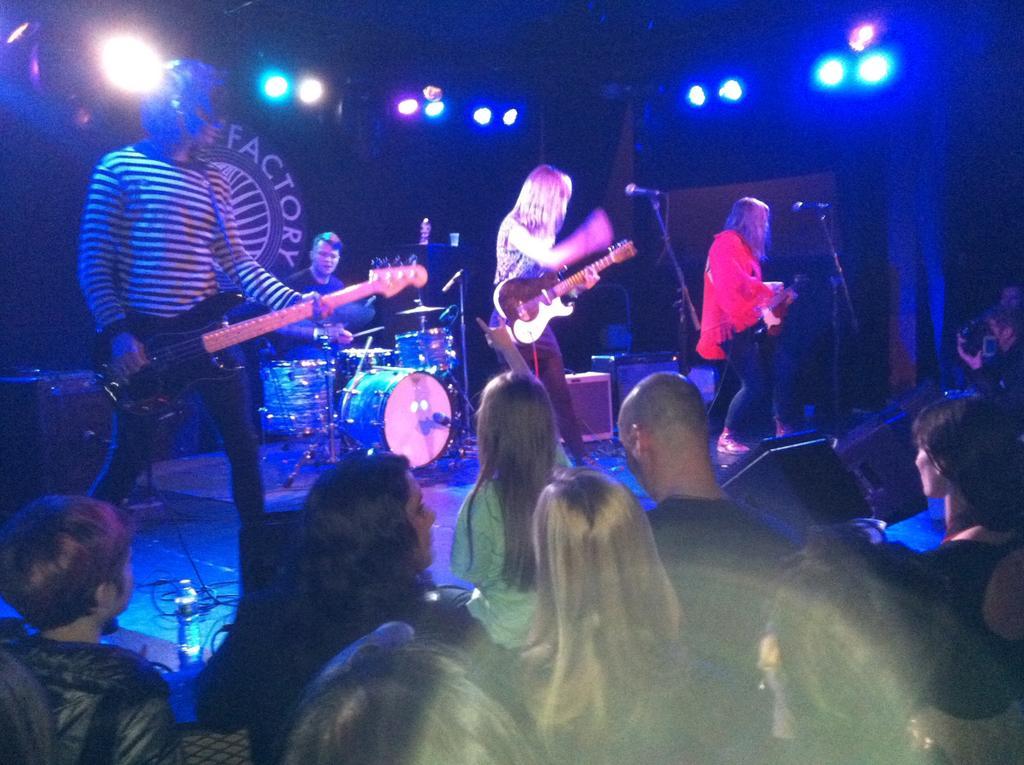How would you summarize this image in a sentence or two? At the top of the image we can see people standing on the dais and holding musical instruments in their hands. In the background there are electric lights, curtain, side table, cables, disposable bottles and mics. At the bottom of the image we can see people standing on the floor. 